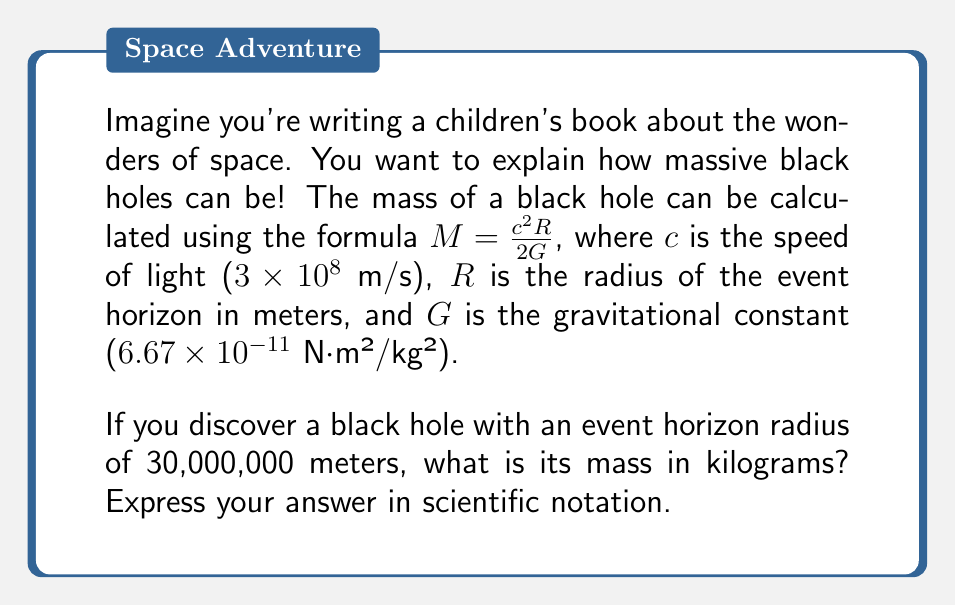Give your solution to this math problem. Let's approach this step-by-step:

1) We're given the formula: $M = \frac{c^2R}{2G}$

2) We know the values:
   $c = 3 \times 10^8$ m/s
   $R = 30,000,000$ m = $3 \times 10^7$ m
   $G = 6.67 \times 10^{-11}$ N⋅m²/kg²

3) Let's substitute these into the formula:

   $$M = \frac{(3 \times 10^8)^2 \times (3 \times 10^7)}{2 \times (6.67 \times 10^{-11})}$$

4) Let's calculate the numerator:
   $(3 \times 10^8)^2 = 9 \times 10^{16}$
   $9 \times 10^{16} \times 3 \times 10^7 = 27 \times 10^{23}$

5) Now our equation looks like:

   $$M = \frac{27 \times 10^{23}}{2 \times (6.67 \times 10^{-11})}$$

6) Simplify:
   $$M = \frac{27 \times 10^{23}}{13.34 \times 10^{-11}}$$

7) Divide:
   $27 \div 13.34 \approx 2.024$
   $10^{23} \div 10^{-11} = 10^{34}$

8) Therefore:
   $$M \approx 2.024 \times 10^{34}$$ kg
Answer: $2.024 \times 10^{34}$ kg 